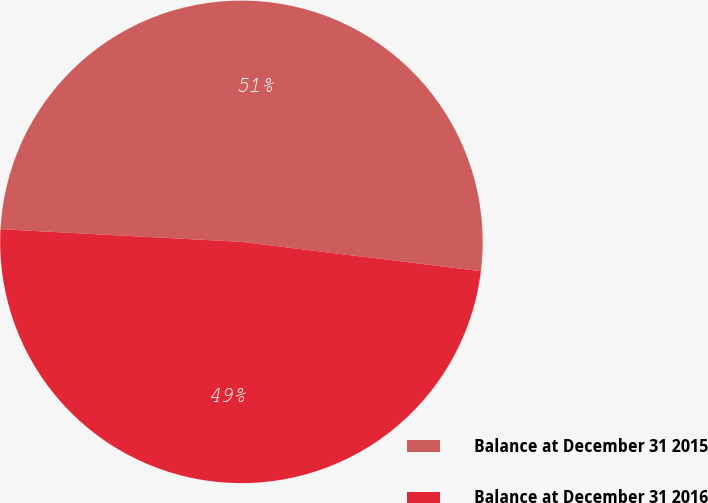Convert chart. <chart><loc_0><loc_0><loc_500><loc_500><pie_chart><fcel>Balance at December 31 2015<fcel>Balance at December 31 2016<nl><fcel>51.1%<fcel>48.9%<nl></chart> 